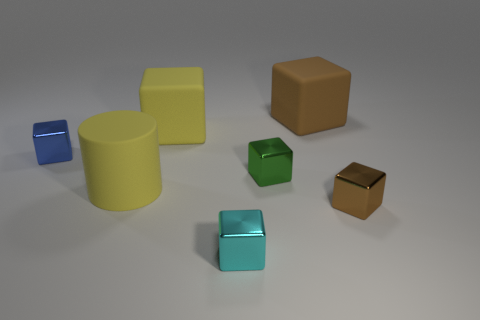Subtract all yellow rubber cubes. How many cubes are left? 5 Subtract all brown blocks. How many blocks are left? 4 Add 2 blue things. How many objects exist? 9 Subtract all blue cylinders. How many brown blocks are left? 2 Subtract all cylinders. How many objects are left? 6 Subtract 4 cubes. How many cubes are left? 2 Subtract all green blocks. Subtract all blue spheres. How many blocks are left? 5 Subtract all big matte blocks. Subtract all tiny green things. How many objects are left? 4 Add 4 big brown objects. How many big brown objects are left? 5 Add 6 tiny cyan cubes. How many tiny cyan cubes exist? 7 